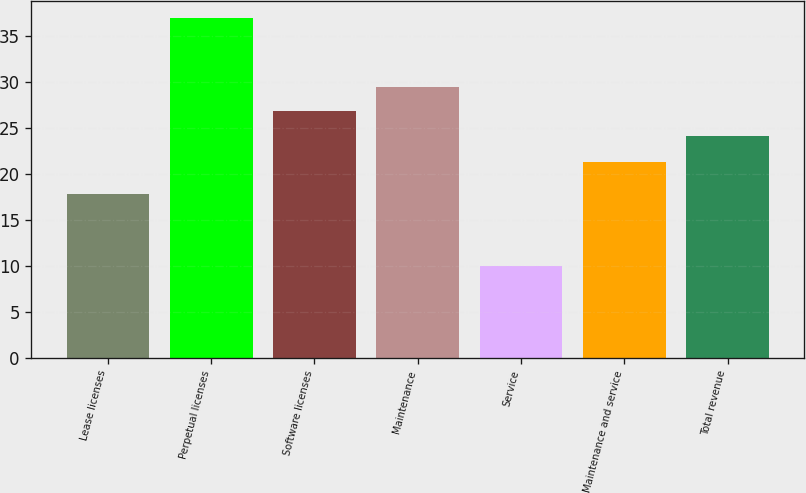Convert chart to OTSL. <chart><loc_0><loc_0><loc_500><loc_500><bar_chart><fcel>Lease licenses<fcel>Perpetual licenses<fcel>Software licenses<fcel>Maintenance<fcel>Service<fcel>Maintenance and service<fcel>Total revenue<nl><fcel>17.8<fcel>37<fcel>26.8<fcel>29.5<fcel>10<fcel>21.3<fcel>24.1<nl></chart> 